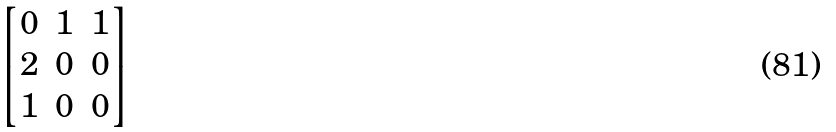<formula> <loc_0><loc_0><loc_500><loc_500>\begin{bmatrix} 0 & 1 & 1 \\ 2 & 0 & 0 \\ 1 & 0 & 0 \end{bmatrix}</formula> 